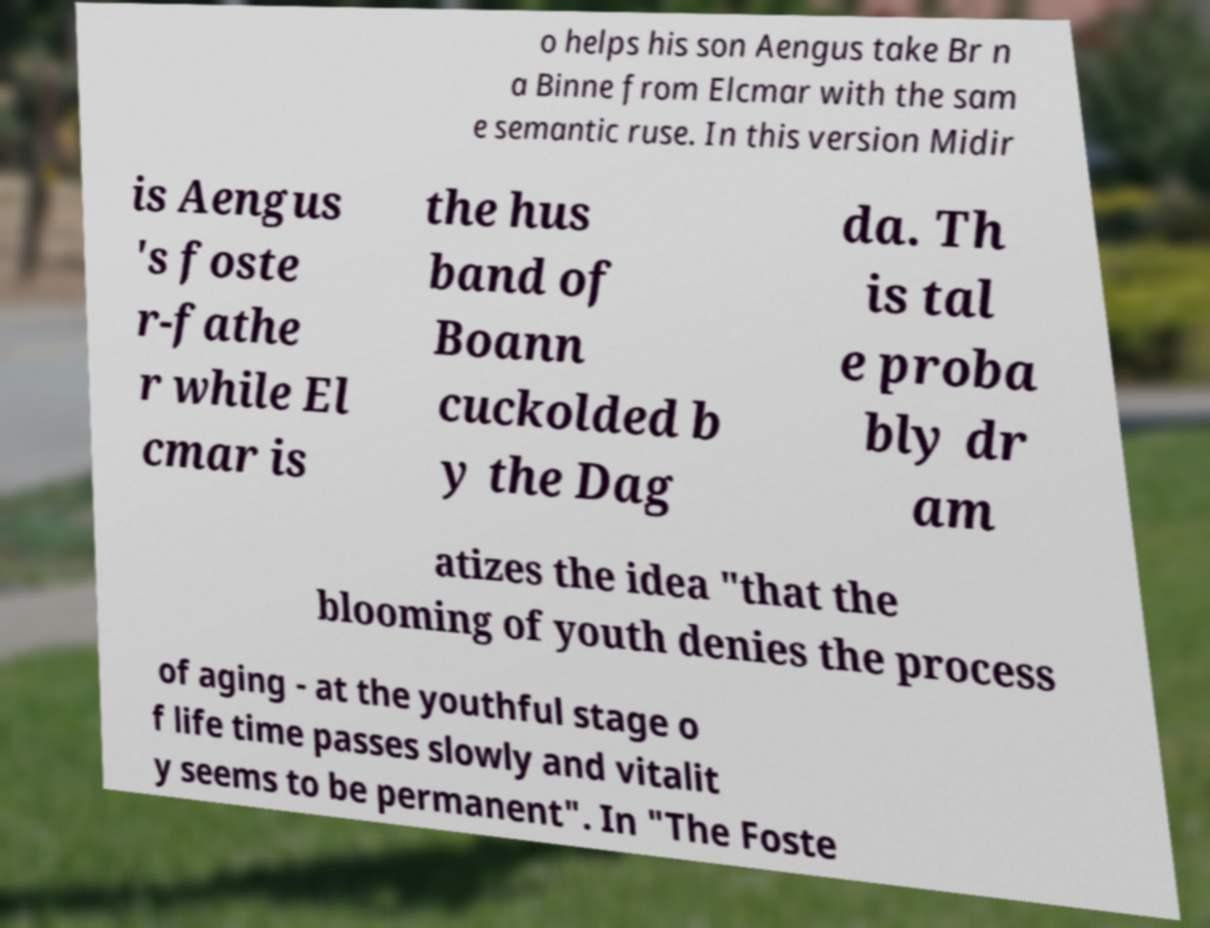I need the written content from this picture converted into text. Can you do that? o helps his son Aengus take Br n a Binne from Elcmar with the sam e semantic ruse. In this version Midir is Aengus 's foste r-fathe r while El cmar is the hus band of Boann cuckolded b y the Dag da. Th is tal e proba bly dr am atizes the idea "that the blooming of youth denies the process of aging - at the youthful stage o f life time passes slowly and vitalit y seems to be permanent". In "The Foste 